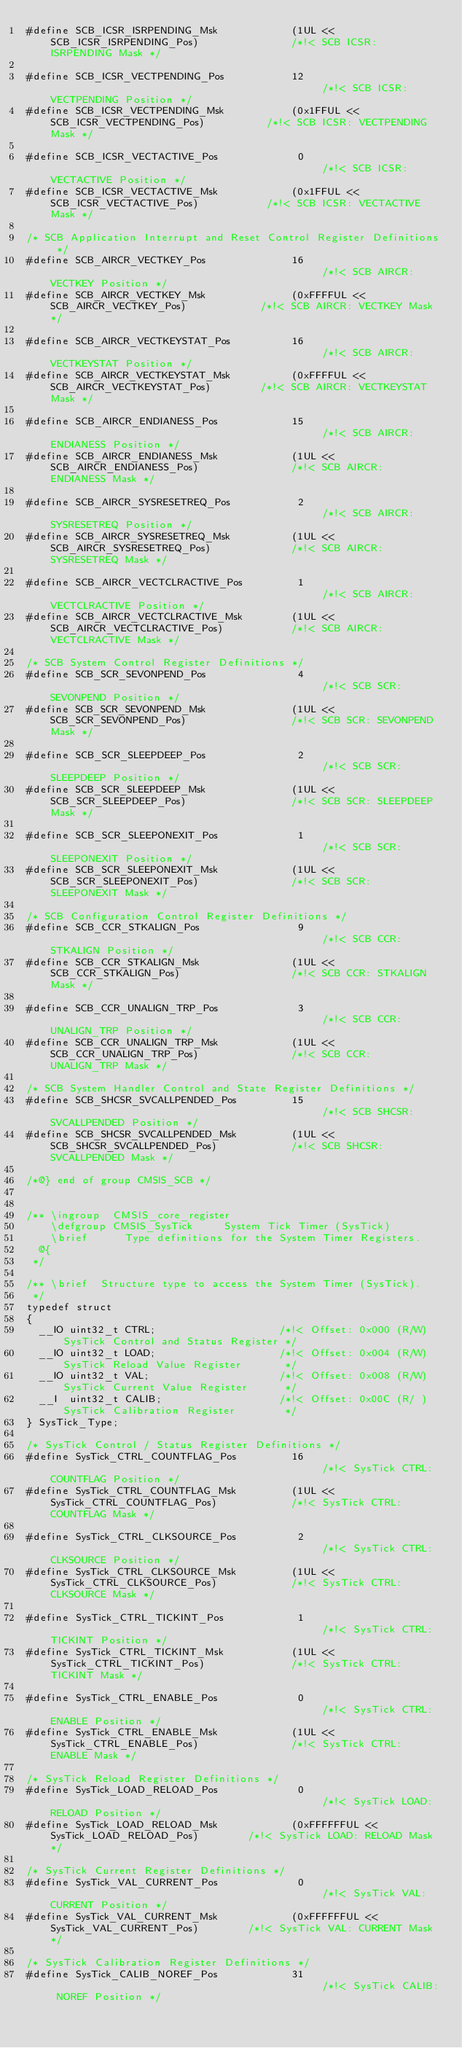<code> <loc_0><loc_0><loc_500><loc_500><_C_>#define SCB_ICSR_ISRPENDING_Msk            (1UL << SCB_ICSR_ISRPENDING_Pos)               /*!< SCB ICSR: ISRPENDING Mask */

#define SCB_ICSR_VECTPENDING_Pos           12                                             /*!< SCB ICSR: VECTPENDING Position */
#define SCB_ICSR_VECTPENDING_Msk           (0x1FFUL << SCB_ICSR_VECTPENDING_Pos)          /*!< SCB ICSR: VECTPENDING Mask */

#define SCB_ICSR_VECTACTIVE_Pos             0                                             /*!< SCB ICSR: VECTACTIVE Position */
#define SCB_ICSR_VECTACTIVE_Msk            (0x1FFUL << SCB_ICSR_VECTACTIVE_Pos)           /*!< SCB ICSR: VECTACTIVE Mask */

/* SCB Application Interrupt and Reset Control Register Definitions */
#define SCB_AIRCR_VECTKEY_Pos              16                                             /*!< SCB AIRCR: VECTKEY Position */
#define SCB_AIRCR_VECTKEY_Msk              (0xFFFFUL << SCB_AIRCR_VECTKEY_Pos)            /*!< SCB AIRCR: VECTKEY Mask */

#define SCB_AIRCR_VECTKEYSTAT_Pos          16                                             /*!< SCB AIRCR: VECTKEYSTAT Position */
#define SCB_AIRCR_VECTKEYSTAT_Msk          (0xFFFFUL << SCB_AIRCR_VECTKEYSTAT_Pos)        /*!< SCB AIRCR: VECTKEYSTAT Mask */

#define SCB_AIRCR_ENDIANESS_Pos            15                                             /*!< SCB AIRCR: ENDIANESS Position */
#define SCB_AIRCR_ENDIANESS_Msk            (1UL << SCB_AIRCR_ENDIANESS_Pos)               /*!< SCB AIRCR: ENDIANESS Mask */

#define SCB_AIRCR_SYSRESETREQ_Pos           2                                             /*!< SCB AIRCR: SYSRESETREQ Position */
#define SCB_AIRCR_SYSRESETREQ_Msk          (1UL << SCB_AIRCR_SYSRESETREQ_Pos)             /*!< SCB AIRCR: SYSRESETREQ Mask */

#define SCB_AIRCR_VECTCLRACTIVE_Pos         1                                             /*!< SCB AIRCR: VECTCLRACTIVE Position */
#define SCB_AIRCR_VECTCLRACTIVE_Msk        (1UL << SCB_AIRCR_VECTCLRACTIVE_Pos)           /*!< SCB AIRCR: VECTCLRACTIVE Mask */

/* SCB System Control Register Definitions */
#define SCB_SCR_SEVONPEND_Pos               4                                             /*!< SCB SCR: SEVONPEND Position */
#define SCB_SCR_SEVONPEND_Msk              (1UL << SCB_SCR_SEVONPEND_Pos)                 /*!< SCB SCR: SEVONPEND Mask */

#define SCB_SCR_SLEEPDEEP_Pos               2                                             /*!< SCB SCR: SLEEPDEEP Position */
#define SCB_SCR_SLEEPDEEP_Msk              (1UL << SCB_SCR_SLEEPDEEP_Pos)                 /*!< SCB SCR: SLEEPDEEP Mask */

#define SCB_SCR_SLEEPONEXIT_Pos             1                                             /*!< SCB SCR: SLEEPONEXIT Position */
#define SCB_SCR_SLEEPONEXIT_Msk            (1UL << SCB_SCR_SLEEPONEXIT_Pos)               /*!< SCB SCR: SLEEPONEXIT Mask */

/* SCB Configuration Control Register Definitions */
#define SCB_CCR_STKALIGN_Pos                9                                             /*!< SCB CCR: STKALIGN Position */
#define SCB_CCR_STKALIGN_Msk               (1UL << SCB_CCR_STKALIGN_Pos)                  /*!< SCB CCR: STKALIGN Mask */

#define SCB_CCR_UNALIGN_TRP_Pos             3                                             /*!< SCB CCR: UNALIGN_TRP Position */
#define SCB_CCR_UNALIGN_TRP_Msk            (1UL << SCB_CCR_UNALIGN_TRP_Pos)               /*!< SCB CCR: UNALIGN_TRP Mask */

/* SCB System Handler Control and State Register Definitions */
#define SCB_SHCSR_SVCALLPENDED_Pos         15                                             /*!< SCB SHCSR: SVCALLPENDED Position */
#define SCB_SHCSR_SVCALLPENDED_Msk         (1UL << SCB_SHCSR_SVCALLPENDED_Pos)            /*!< SCB SHCSR: SVCALLPENDED Mask */

/*@} end of group CMSIS_SCB */


/** \ingroup  CMSIS_core_register
    \defgroup CMSIS_SysTick     System Tick Timer (SysTick)
    \brief      Type definitions for the System Timer Registers.
  @{
 */

/** \brief  Structure type to access the System Timer (SysTick).
 */
typedef struct
{
  __IO uint32_t CTRL;                    /*!< Offset: 0x000 (R/W)  SysTick Control and Status Register */
  __IO uint32_t LOAD;                    /*!< Offset: 0x004 (R/W)  SysTick Reload Value Register       */
  __IO uint32_t VAL;                     /*!< Offset: 0x008 (R/W)  SysTick Current Value Register      */
  __I  uint32_t CALIB;                   /*!< Offset: 0x00C (R/ )  SysTick Calibration Register        */
} SysTick_Type;

/* SysTick Control / Status Register Definitions */
#define SysTick_CTRL_COUNTFLAG_Pos         16                                             /*!< SysTick CTRL: COUNTFLAG Position */
#define SysTick_CTRL_COUNTFLAG_Msk         (1UL << SysTick_CTRL_COUNTFLAG_Pos)            /*!< SysTick CTRL: COUNTFLAG Mask */

#define SysTick_CTRL_CLKSOURCE_Pos          2                                             /*!< SysTick CTRL: CLKSOURCE Position */
#define SysTick_CTRL_CLKSOURCE_Msk         (1UL << SysTick_CTRL_CLKSOURCE_Pos)            /*!< SysTick CTRL: CLKSOURCE Mask */

#define SysTick_CTRL_TICKINT_Pos            1                                             /*!< SysTick CTRL: TICKINT Position */
#define SysTick_CTRL_TICKINT_Msk           (1UL << SysTick_CTRL_TICKINT_Pos)              /*!< SysTick CTRL: TICKINT Mask */

#define SysTick_CTRL_ENABLE_Pos             0                                             /*!< SysTick CTRL: ENABLE Position */
#define SysTick_CTRL_ENABLE_Msk            (1UL << SysTick_CTRL_ENABLE_Pos)               /*!< SysTick CTRL: ENABLE Mask */

/* SysTick Reload Register Definitions */
#define SysTick_LOAD_RELOAD_Pos             0                                             /*!< SysTick LOAD: RELOAD Position */
#define SysTick_LOAD_RELOAD_Msk            (0xFFFFFFUL << SysTick_LOAD_RELOAD_Pos)        /*!< SysTick LOAD: RELOAD Mask */

/* SysTick Current Register Definitions */
#define SysTick_VAL_CURRENT_Pos             0                                             /*!< SysTick VAL: CURRENT Position */
#define SysTick_VAL_CURRENT_Msk            (0xFFFFFFUL << SysTick_VAL_CURRENT_Pos)        /*!< SysTick VAL: CURRENT Mask */

/* SysTick Calibration Register Definitions */
#define SysTick_CALIB_NOREF_Pos            31                                             /*!< SysTick CALIB: NOREF Position */</code> 